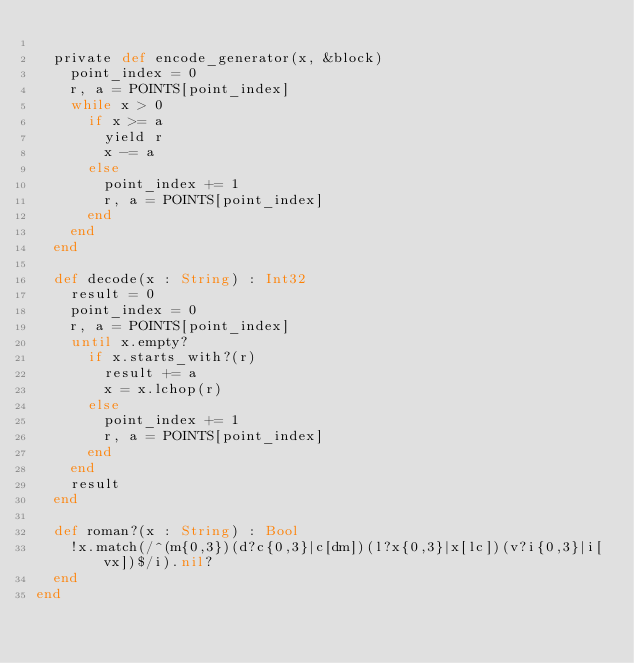<code> <loc_0><loc_0><loc_500><loc_500><_Crystal_>
  private def encode_generator(x, &block)
    point_index = 0
    r, a = POINTS[point_index]
    while x > 0
      if x >= a
        yield r
        x -= a
      else
        point_index += 1
        r, a = POINTS[point_index]
      end
    end
  end

  def decode(x : String) : Int32
    result = 0
    point_index = 0
    r, a = POINTS[point_index]
    until x.empty?
      if x.starts_with?(r)
        result += a
        x = x.lchop(r)
      else
        point_index += 1
        r, a = POINTS[point_index]
      end
    end
    result
  end

  def roman?(x : String) : Bool
    !x.match(/^(m{0,3})(d?c{0,3}|c[dm])(l?x{0,3}|x[lc])(v?i{0,3}|i[vx])$/i).nil?
  end
end
</code> 